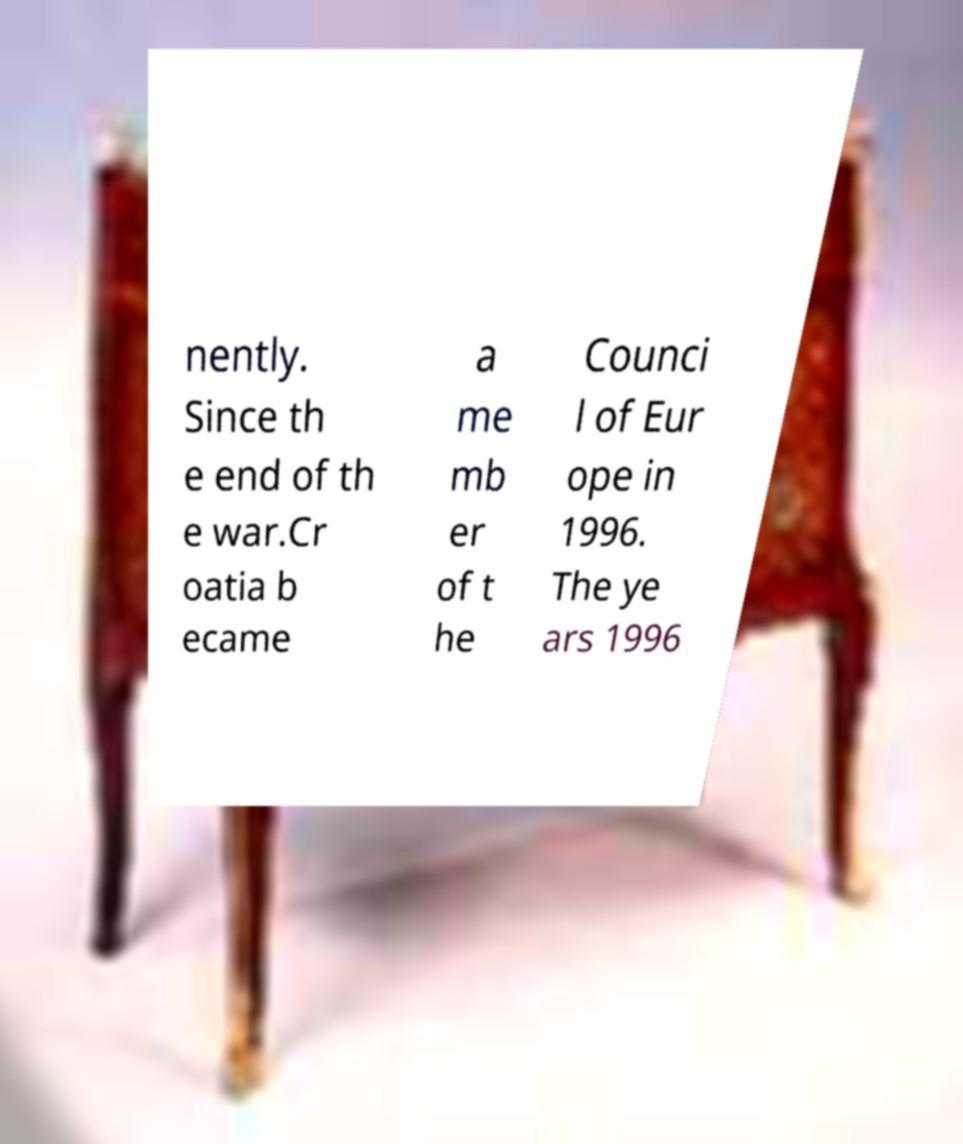Can you read and provide the text displayed in the image?This photo seems to have some interesting text. Can you extract and type it out for me? nently. Since th e end of th e war.Cr oatia b ecame a me mb er of t he Counci l of Eur ope in 1996. The ye ars 1996 